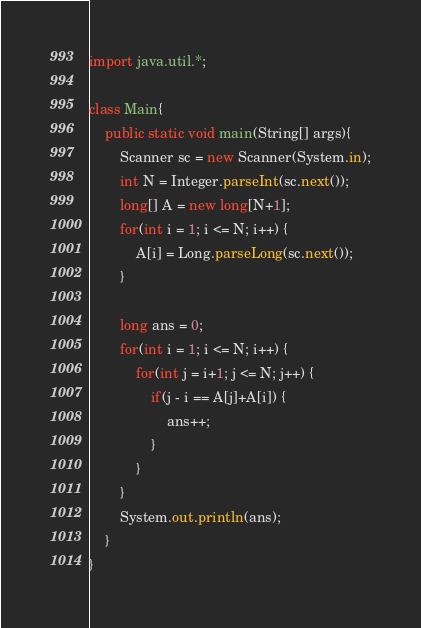Convert code to text. <code><loc_0><loc_0><loc_500><loc_500><_Java_>import java.util.*;
 
class Main{
    public static void main(String[] args){
        Scanner sc = new Scanner(System.in);
        int N = Integer.parseInt(sc.next());
        long[] A = new long[N+1];
        for(int i = 1; i <= N; i++) {
            A[i] = Long.parseLong(sc.next());
        }
        
        long ans = 0;
        for(int i = 1; i <= N; i++) {
            for(int j = i+1; j <= N; j++) {
                if(j - i == A[j]+A[i]) {
                    ans++;
                }
            }
        }
        System.out.println(ans);
    }
}</code> 